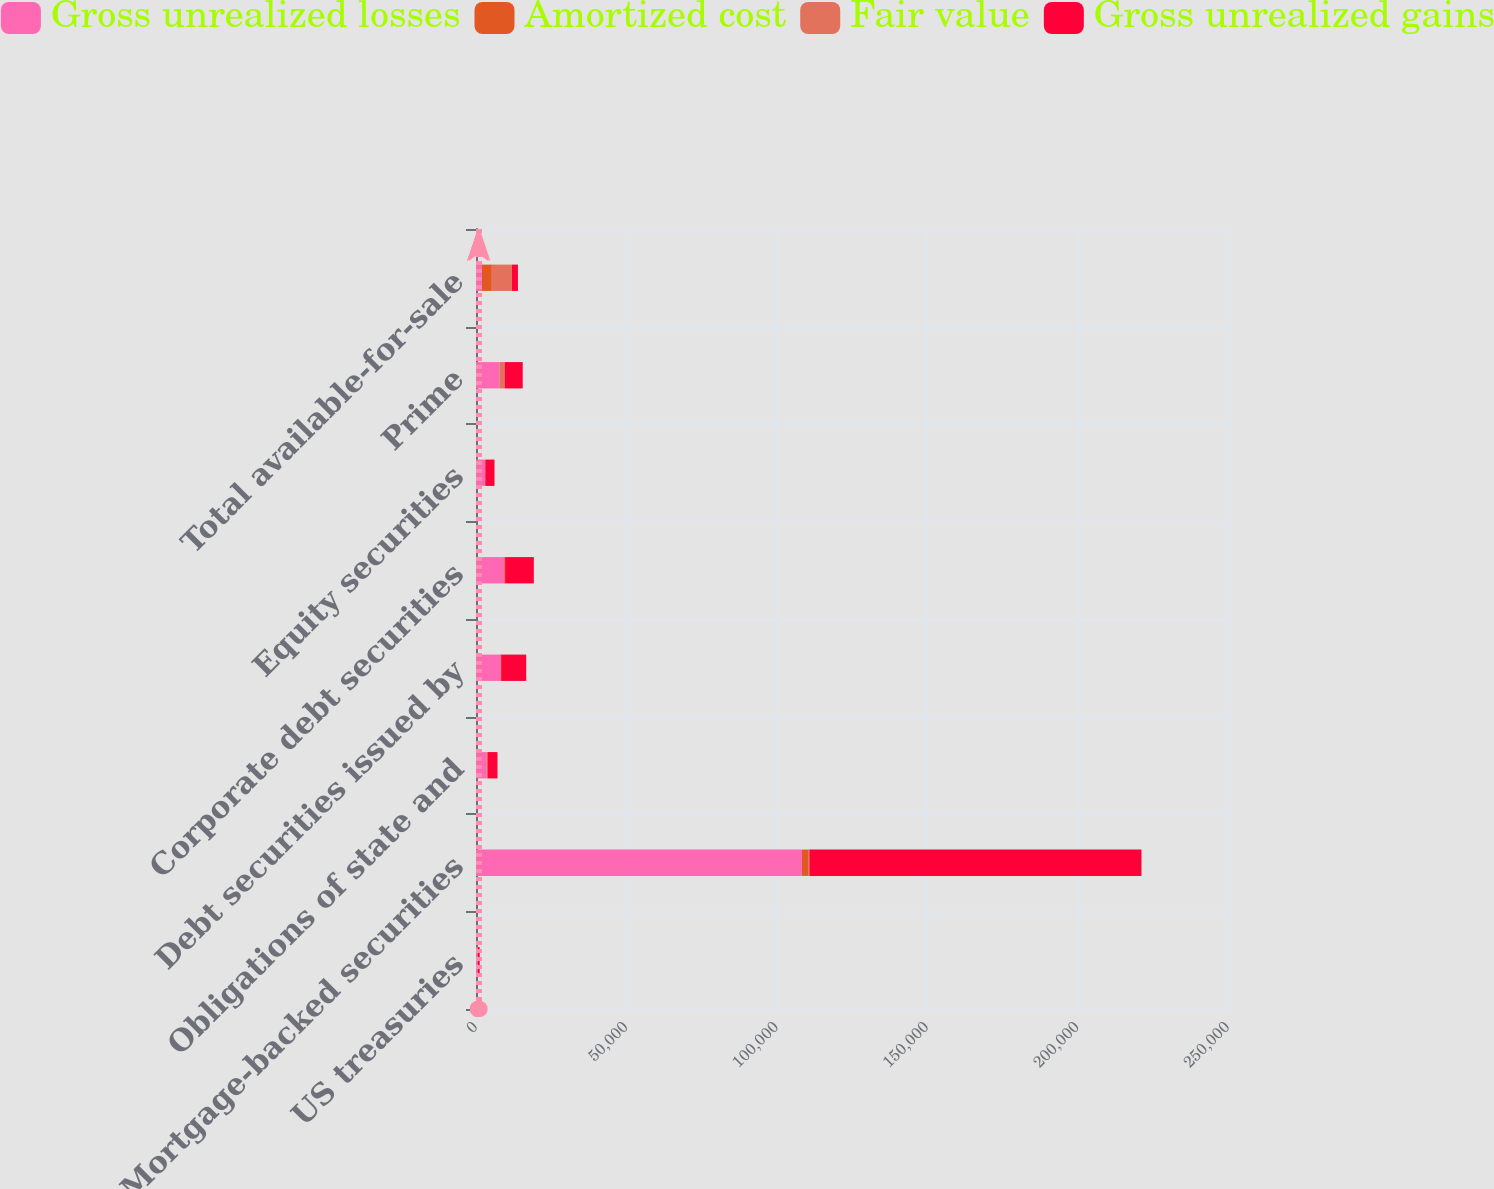Convert chart to OTSL. <chart><loc_0><loc_0><loc_500><loc_500><stacked_bar_chart><ecel><fcel>US treasuries<fcel>Mortgage-backed securities<fcel>Obligations of state and<fcel>Debt securities issued by<fcel>Corporate debt securities<fcel>Equity securities<fcel>Prime<fcel>Total available-for-sale<nl><fcel>Gross unrealized losses<fcel>616<fcel>108360<fcel>3479<fcel>8173<fcel>9358<fcel>3073<fcel>7762<fcel>1998<nl><fcel>Amortized cost<fcel>2<fcel>2257<fcel>94<fcel>173<fcel>257<fcel>2<fcel>4<fcel>3264<nl><fcel>Fair value<fcel>7<fcel>214<fcel>238<fcel>2<fcel>61<fcel>7<fcel>1739<fcel>6683<nl><fcel>Gross unrealized gains<fcel>611<fcel>110403<fcel>3335<fcel>8344<fcel>9554<fcel>3068<fcel>6027<fcel>1998<nl></chart> 